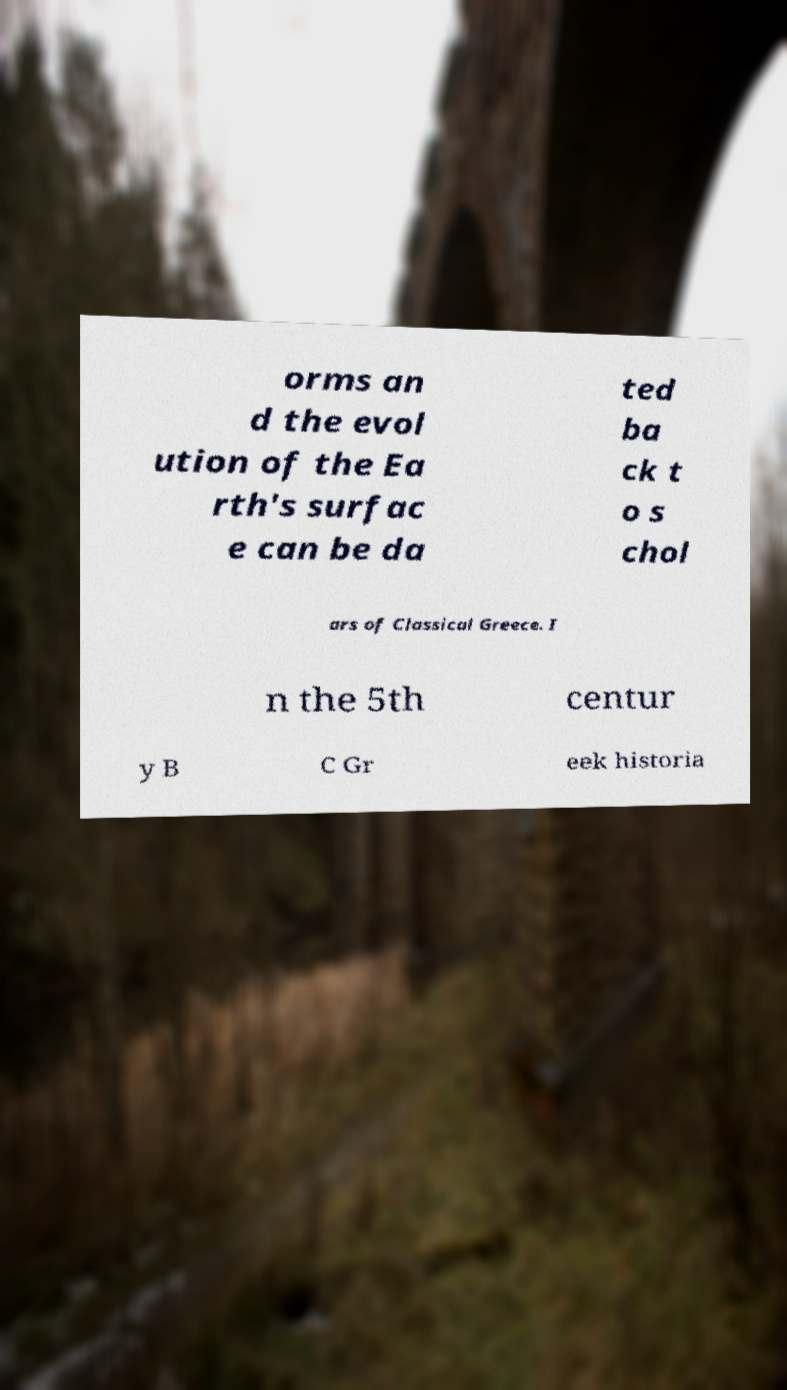For documentation purposes, I need the text within this image transcribed. Could you provide that? orms an d the evol ution of the Ea rth's surfac e can be da ted ba ck t o s chol ars of Classical Greece. I n the 5th centur y B C Gr eek historia 